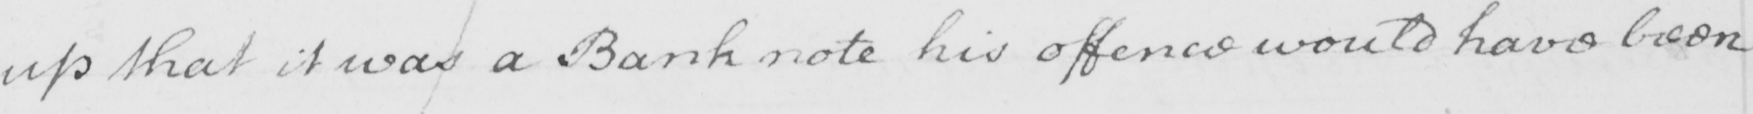What text is written in this handwritten line? up that it was Bank note his offence would have been 